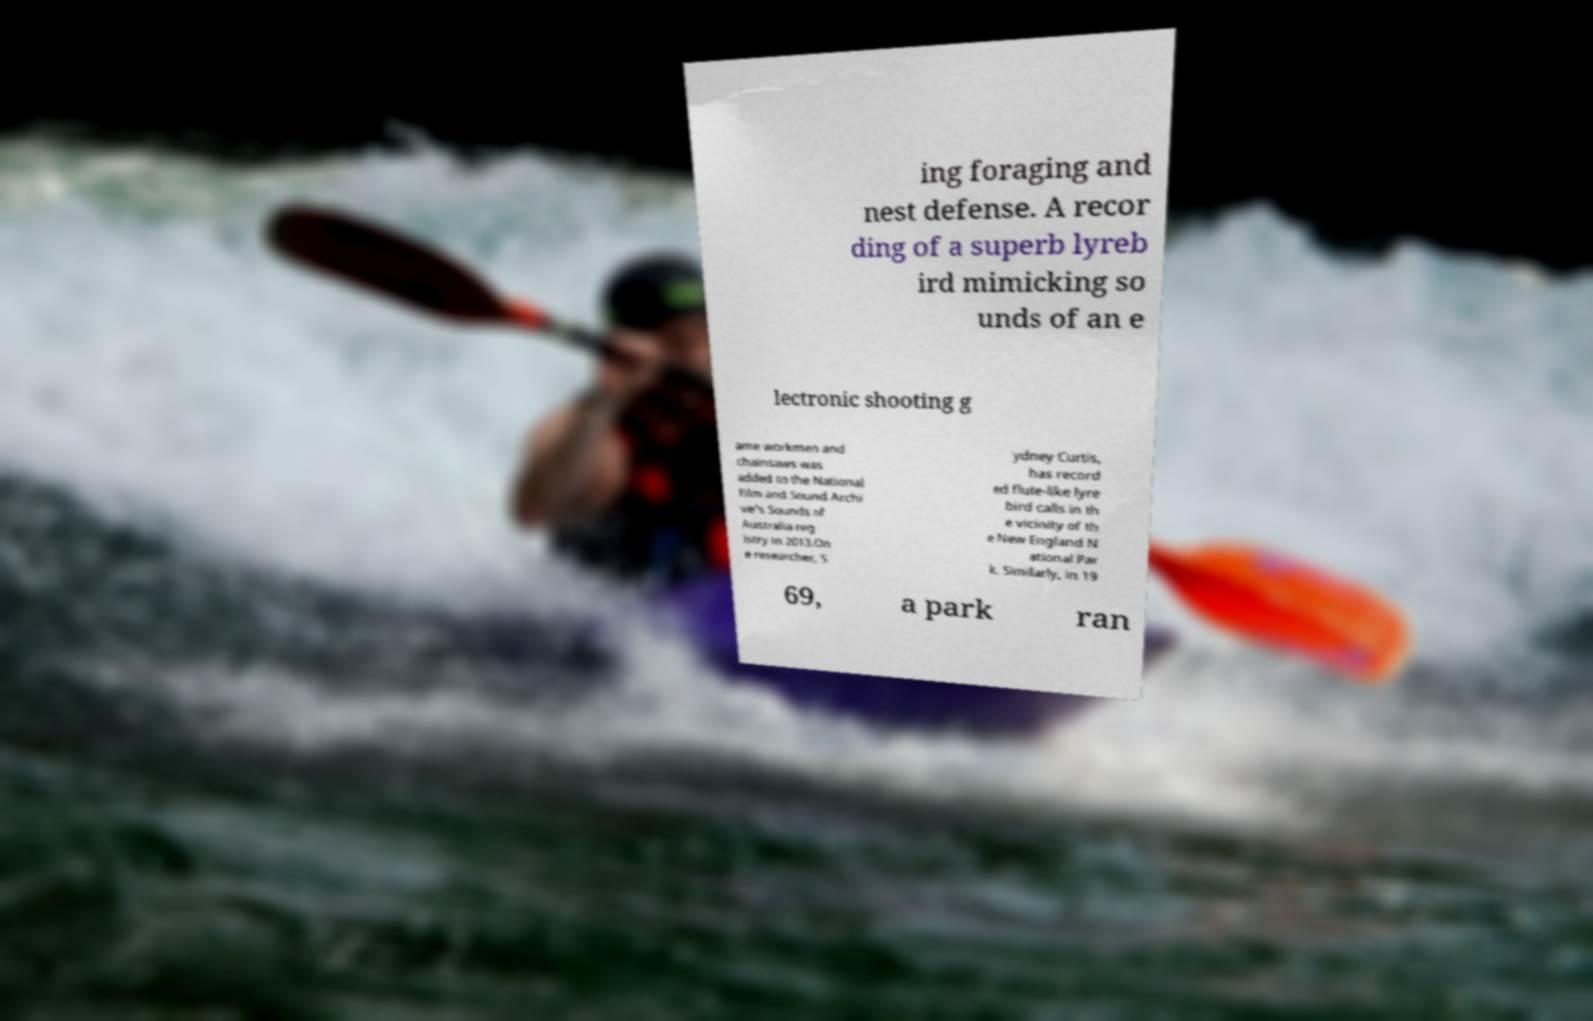Please identify and transcribe the text found in this image. ing foraging and nest defense. A recor ding of a superb lyreb ird mimicking so unds of an e lectronic shooting g ame workmen and chainsaws was added to the National Film and Sound Archi ve's Sounds of Australia reg istry in 2013.On e researcher, S ydney Curtis, has record ed flute-like lyre bird calls in th e vicinity of th e New England N ational Par k. Similarly, in 19 69, a park ran 